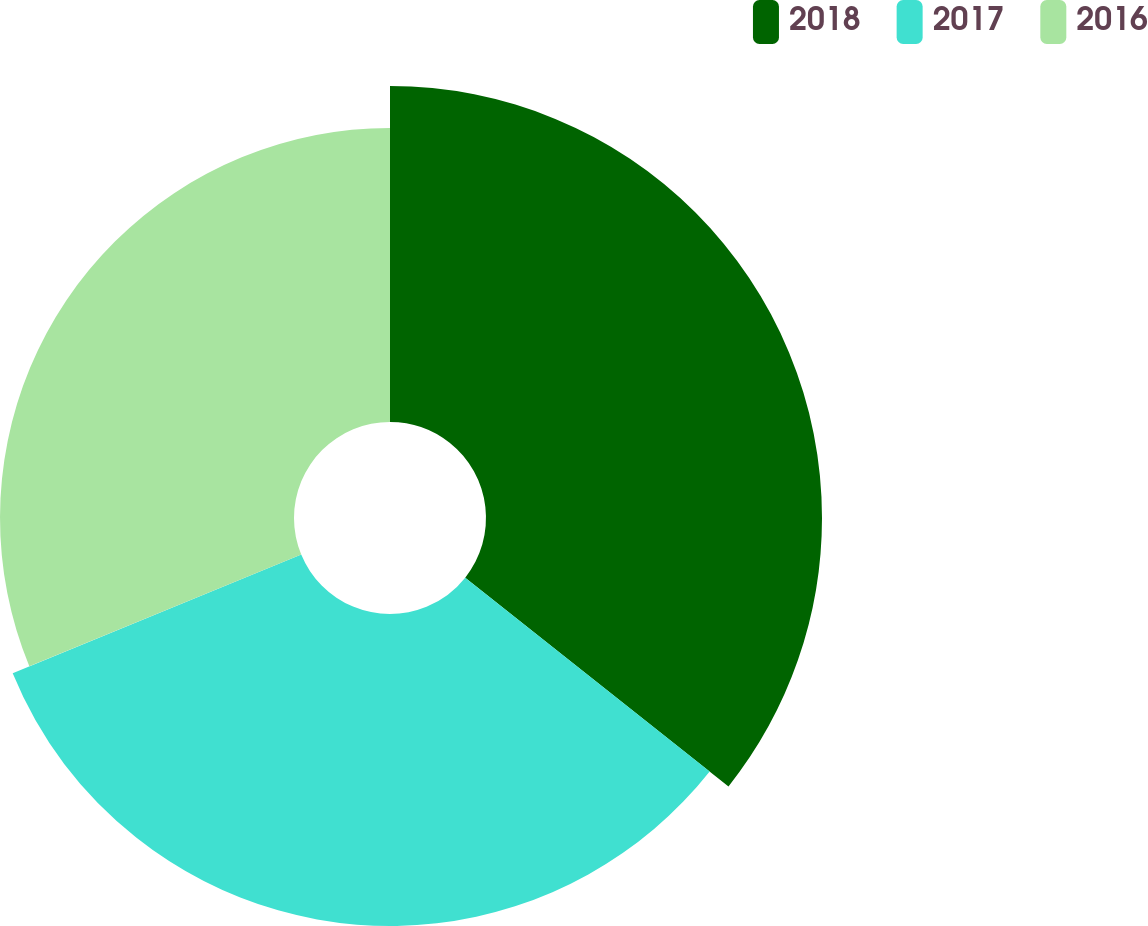<chart> <loc_0><loc_0><loc_500><loc_500><pie_chart><fcel>2018<fcel>2017<fcel>2016<nl><fcel>35.67%<fcel>33.12%<fcel>31.21%<nl></chart> 